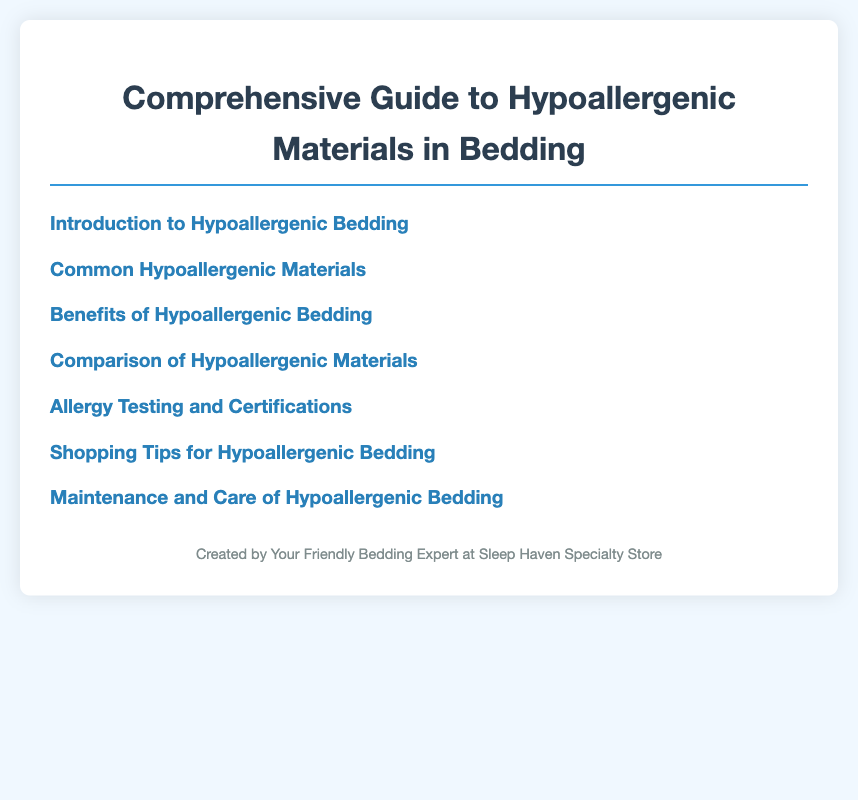What is the first section in the table of contents? The first section in the table of contents is titled "Introduction to Hypoallergenic Bedding."
Answer: Introduction to Hypoallergenic Bedding How many common hypoallergenic materials are listed? There are five common hypoallergenic materials listed in the document.
Answer: 5 What are the two main subsections under the first section? The two subsections under the first section are "Understanding Hypoallergenic Materials" and "Importance of Hypoallergenic Bedding."
Answer: Understanding Hypoallergenic Materials, Importance of Hypoallergenic Bedding Which material is mentioned last in the common hypoallergenic materials section? The last material mentioned in the section is wool.
Answer: Wool What is one benefit of hypoallergenic bedding? One benefit of hypoallergenic bedding is an improved sleep quality.
Answer: Improved Sleep Quality How many certifications are mentioned under allergy testing? Three certifications are mentioned under allergy testing.
Answer: 3 What shopping tip is provided for buying hypoallergenic bedding? One shopping tip provided is to read labels and certificates.
Answer: Reading Labels and Certificates What does the maintenance section address? The maintenance section addresses washing and drying guidelines, storage tips, and preventing allergen build-up.
Answer: Washing and Drying Guidelines, Storage Tips, Preventing Allergen Build-up 